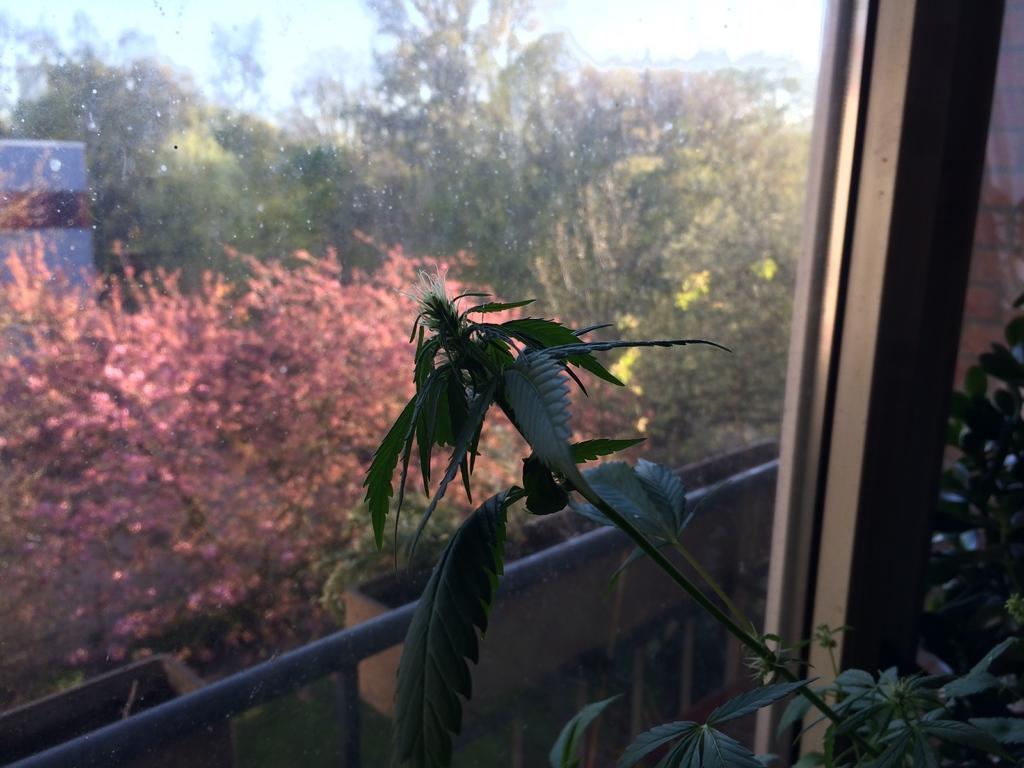Please provide a concise description of this image. In this image there is a glass door and few plants, outside the glass door there are few trees and the sky. 